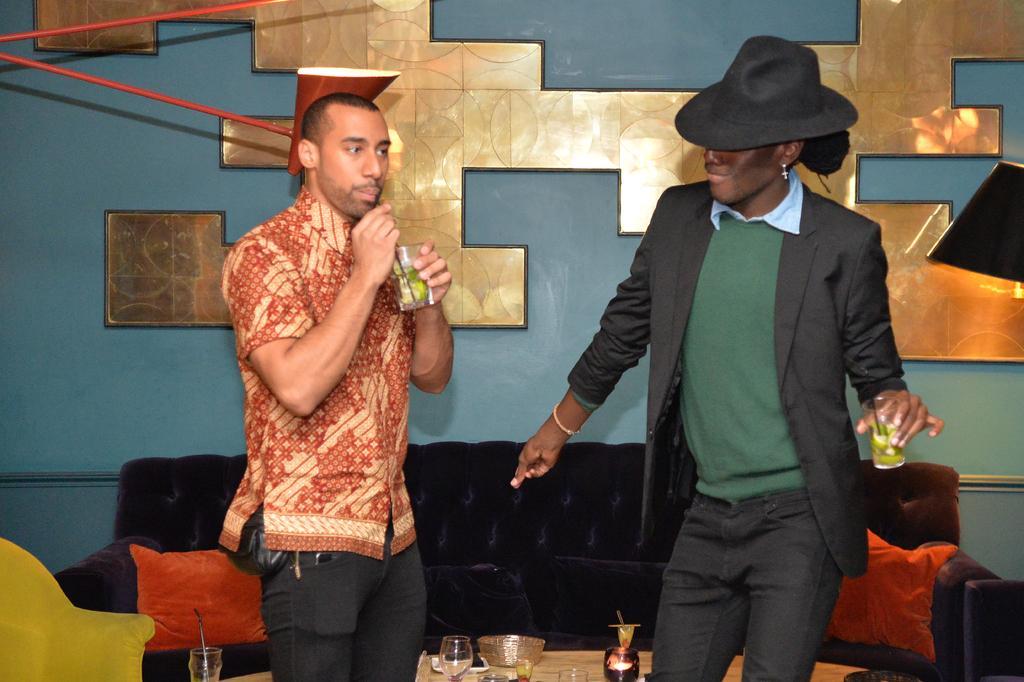Please provide a concise description of this image. This image consists of two persons standing and drinking the juice. In the background, we can see a frame on the wall. And there is a sofa in black color. On the left, there is a chair in yellow color. At the bottom, we can see a table on which there are glasses kept. 